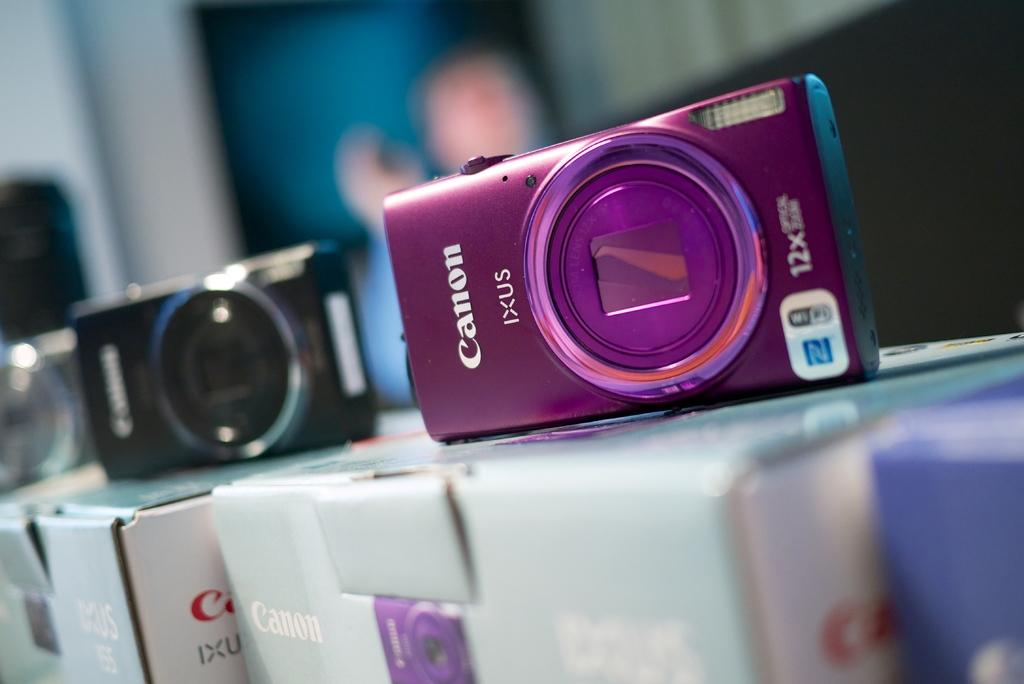<image>
Present a compact description of the photo's key features. Several Canon digital cameras sit on display on top of their boxes. 